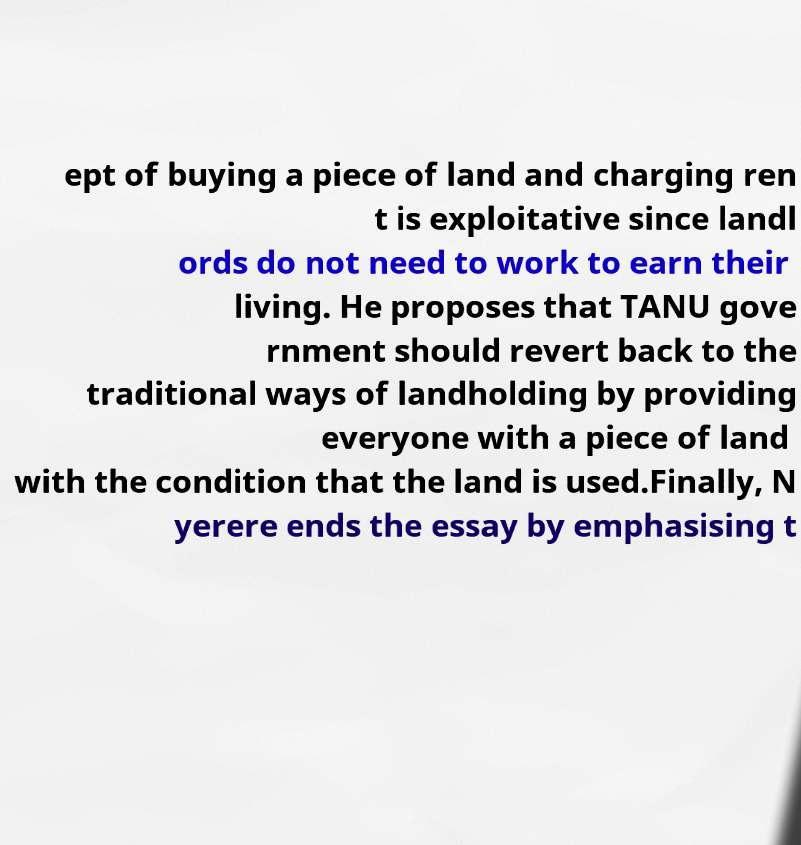I need the written content from this picture converted into text. Can you do that? ept of buying a piece of land and charging ren t is exploitative since landl ords do not need to work to earn their living. He proposes that TANU gove rnment should revert back to the traditional ways of landholding by providing everyone with a piece of land with the condition that the land is used.Finally, N yerere ends the essay by emphasising t 